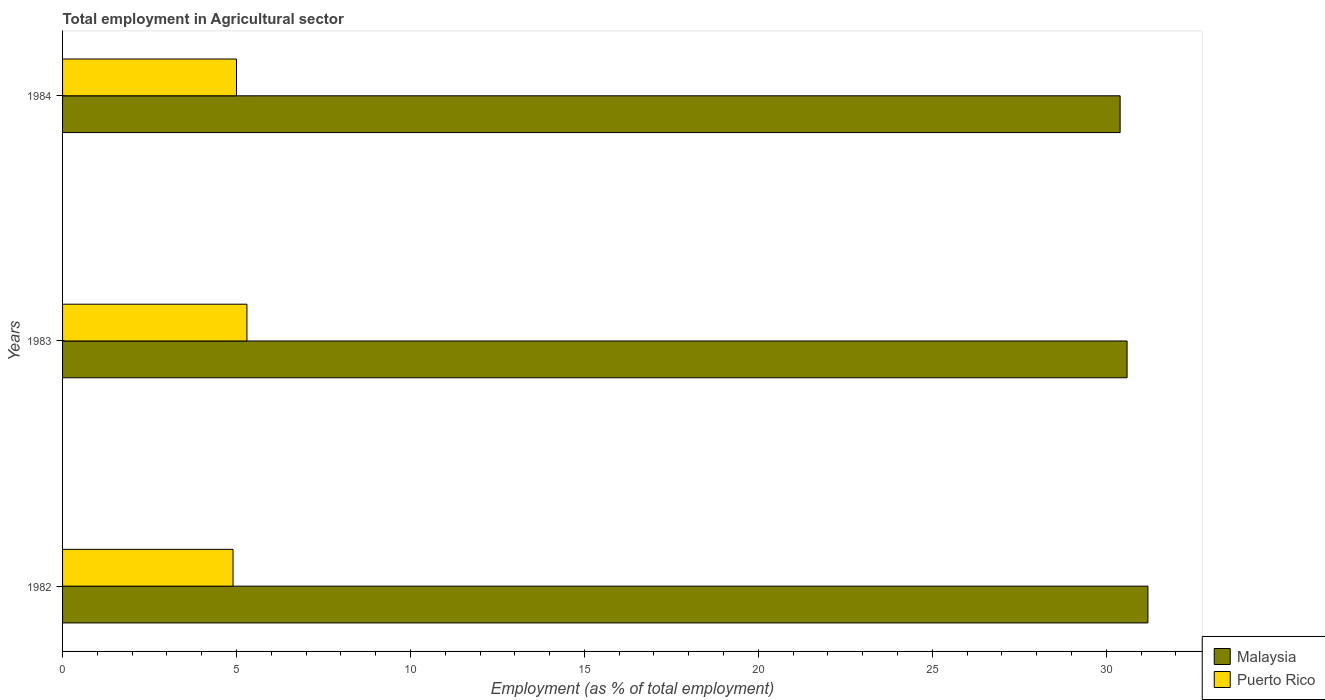How many different coloured bars are there?
Make the answer very short. 2. How many groups of bars are there?
Give a very brief answer. 3. Are the number of bars per tick equal to the number of legend labels?
Your response must be concise. Yes. How many bars are there on the 3rd tick from the bottom?
Give a very brief answer. 2. In how many cases, is the number of bars for a given year not equal to the number of legend labels?
Give a very brief answer. 0. What is the employment in agricultural sector in Malaysia in 1983?
Provide a succinct answer. 30.6. Across all years, what is the maximum employment in agricultural sector in Puerto Rico?
Make the answer very short. 5.3. Across all years, what is the minimum employment in agricultural sector in Malaysia?
Your answer should be very brief. 30.4. In which year was the employment in agricultural sector in Malaysia minimum?
Make the answer very short. 1984. What is the total employment in agricultural sector in Malaysia in the graph?
Provide a short and direct response. 92.2. What is the difference between the employment in agricultural sector in Malaysia in 1982 and that in 1984?
Offer a very short reply. 0.8. What is the difference between the employment in agricultural sector in Malaysia in 1983 and the employment in agricultural sector in Puerto Rico in 1984?
Provide a succinct answer. 25.6. What is the average employment in agricultural sector in Malaysia per year?
Make the answer very short. 30.73. In the year 1983, what is the difference between the employment in agricultural sector in Puerto Rico and employment in agricultural sector in Malaysia?
Make the answer very short. -25.3. What is the ratio of the employment in agricultural sector in Puerto Rico in 1982 to that in 1984?
Ensure brevity in your answer.  0.98. Is the difference between the employment in agricultural sector in Puerto Rico in 1983 and 1984 greater than the difference between the employment in agricultural sector in Malaysia in 1983 and 1984?
Offer a terse response. Yes. What is the difference between the highest and the second highest employment in agricultural sector in Malaysia?
Ensure brevity in your answer.  0.6. What is the difference between the highest and the lowest employment in agricultural sector in Malaysia?
Offer a very short reply. 0.8. What does the 1st bar from the top in 1984 represents?
Give a very brief answer. Puerto Rico. What does the 1st bar from the bottom in 1984 represents?
Your response must be concise. Malaysia. Are all the bars in the graph horizontal?
Give a very brief answer. Yes. How many years are there in the graph?
Your answer should be very brief. 3. Does the graph contain any zero values?
Your response must be concise. No. Does the graph contain grids?
Provide a short and direct response. No. What is the title of the graph?
Offer a terse response. Total employment in Agricultural sector. What is the label or title of the X-axis?
Give a very brief answer. Employment (as % of total employment). What is the label or title of the Y-axis?
Keep it short and to the point. Years. What is the Employment (as % of total employment) of Malaysia in 1982?
Make the answer very short. 31.2. What is the Employment (as % of total employment) in Puerto Rico in 1982?
Provide a succinct answer. 4.9. What is the Employment (as % of total employment) in Malaysia in 1983?
Offer a very short reply. 30.6. What is the Employment (as % of total employment) in Puerto Rico in 1983?
Provide a succinct answer. 5.3. What is the Employment (as % of total employment) in Malaysia in 1984?
Provide a succinct answer. 30.4. What is the Employment (as % of total employment) in Puerto Rico in 1984?
Ensure brevity in your answer.  5. Across all years, what is the maximum Employment (as % of total employment) of Malaysia?
Your response must be concise. 31.2. Across all years, what is the maximum Employment (as % of total employment) of Puerto Rico?
Keep it short and to the point. 5.3. Across all years, what is the minimum Employment (as % of total employment) of Malaysia?
Your response must be concise. 30.4. Across all years, what is the minimum Employment (as % of total employment) of Puerto Rico?
Offer a very short reply. 4.9. What is the total Employment (as % of total employment) of Malaysia in the graph?
Your response must be concise. 92.2. What is the difference between the Employment (as % of total employment) in Malaysia in 1982 and that in 1983?
Keep it short and to the point. 0.6. What is the difference between the Employment (as % of total employment) in Malaysia in 1982 and that in 1984?
Your response must be concise. 0.8. What is the difference between the Employment (as % of total employment) of Malaysia in 1983 and that in 1984?
Ensure brevity in your answer.  0.2. What is the difference between the Employment (as % of total employment) in Malaysia in 1982 and the Employment (as % of total employment) in Puerto Rico in 1983?
Provide a short and direct response. 25.9. What is the difference between the Employment (as % of total employment) of Malaysia in 1982 and the Employment (as % of total employment) of Puerto Rico in 1984?
Give a very brief answer. 26.2. What is the difference between the Employment (as % of total employment) of Malaysia in 1983 and the Employment (as % of total employment) of Puerto Rico in 1984?
Provide a short and direct response. 25.6. What is the average Employment (as % of total employment) of Malaysia per year?
Give a very brief answer. 30.73. What is the average Employment (as % of total employment) in Puerto Rico per year?
Ensure brevity in your answer.  5.07. In the year 1982, what is the difference between the Employment (as % of total employment) of Malaysia and Employment (as % of total employment) of Puerto Rico?
Offer a very short reply. 26.3. In the year 1983, what is the difference between the Employment (as % of total employment) in Malaysia and Employment (as % of total employment) in Puerto Rico?
Give a very brief answer. 25.3. In the year 1984, what is the difference between the Employment (as % of total employment) in Malaysia and Employment (as % of total employment) in Puerto Rico?
Your answer should be very brief. 25.4. What is the ratio of the Employment (as % of total employment) in Malaysia in 1982 to that in 1983?
Ensure brevity in your answer.  1.02. What is the ratio of the Employment (as % of total employment) of Puerto Rico in 1982 to that in 1983?
Your answer should be very brief. 0.92. What is the ratio of the Employment (as % of total employment) of Malaysia in 1982 to that in 1984?
Provide a short and direct response. 1.03. What is the ratio of the Employment (as % of total employment) in Puerto Rico in 1982 to that in 1984?
Your response must be concise. 0.98. What is the ratio of the Employment (as % of total employment) in Malaysia in 1983 to that in 1984?
Make the answer very short. 1.01. What is the ratio of the Employment (as % of total employment) in Puerto Rico in 1983 to that in 1984?
Provide a short and direct response. 1.06. What is the difference between the highest and the second highest Employment (as % of total employment) of Malaysia?
Ensure brevity in your answer.  0.6. What is the difference between the highest and the lowest Employment (as % of total employment) in Puerto Rico?
Your response must be concise. 0.4. 